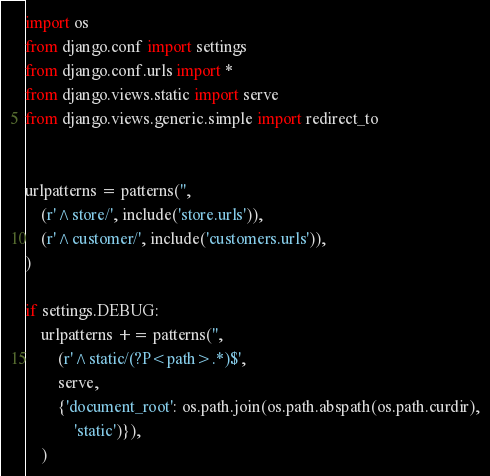Convert code to text. <code><loc_0><loc_0><loc_500><loc_500><_Python_>import os
from django.conf import settings
from django.conf.urls import *
from django.views.static import serve
from django.views.generic.simple import redirect_to


urlpatterns = patterns('',
    (r'^store/', include('store.urls')),
    (r'^customer/', include('customers.urls')),
)

if settings.DEBUG:
    urlpatterns += patterns('',
        (r'^static/(?P<path>.*)$',
        serve,
        {'document_root': os.path.join(os.path.abspath(os.path.curdir),
            'static')}),
    )
</code> 